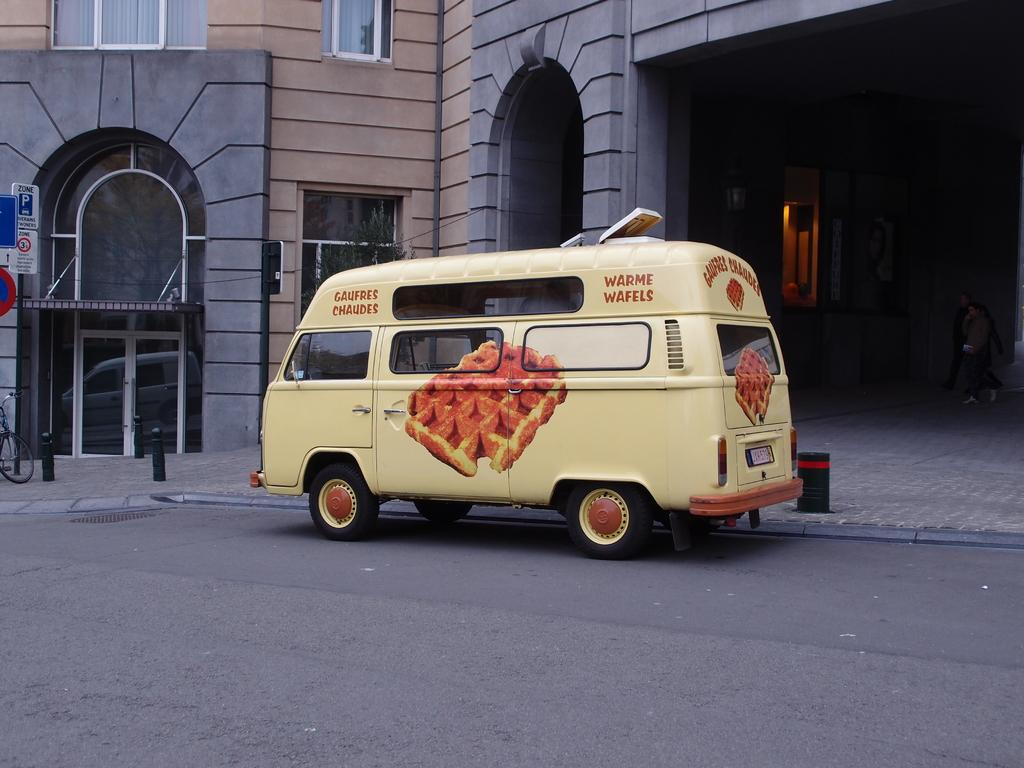What type of vehicle is on the road in the image? There is a van on the road in the image. What else can be seen in the image besides the van? There are buildings visible in the image. What are the boards with text used for in the image? The boards with text might be used for advertising or conveying information. What is on the sidewalk in the image? There is a bicycle on the sidewalk in the image. Can you hear the voice of the rain in the image? There is no rain or voice present in the image; it is a still image. 